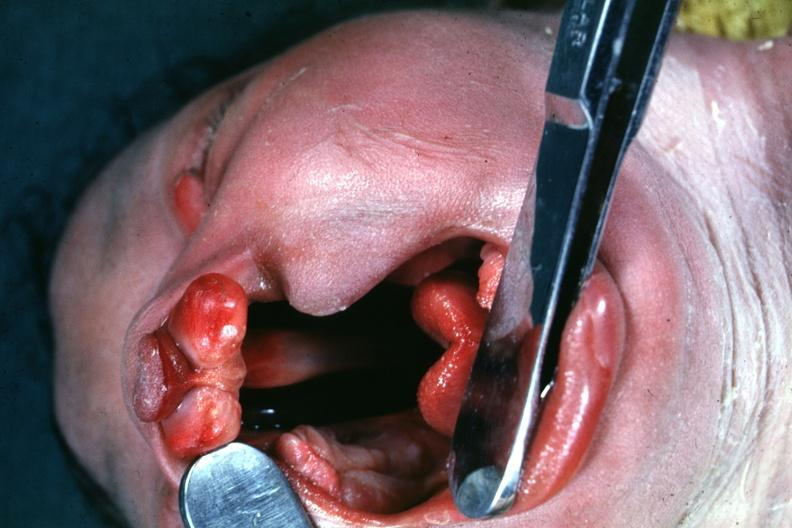what does this image show?
Answer the question using a single word or phrase. Head tilted with mouth 